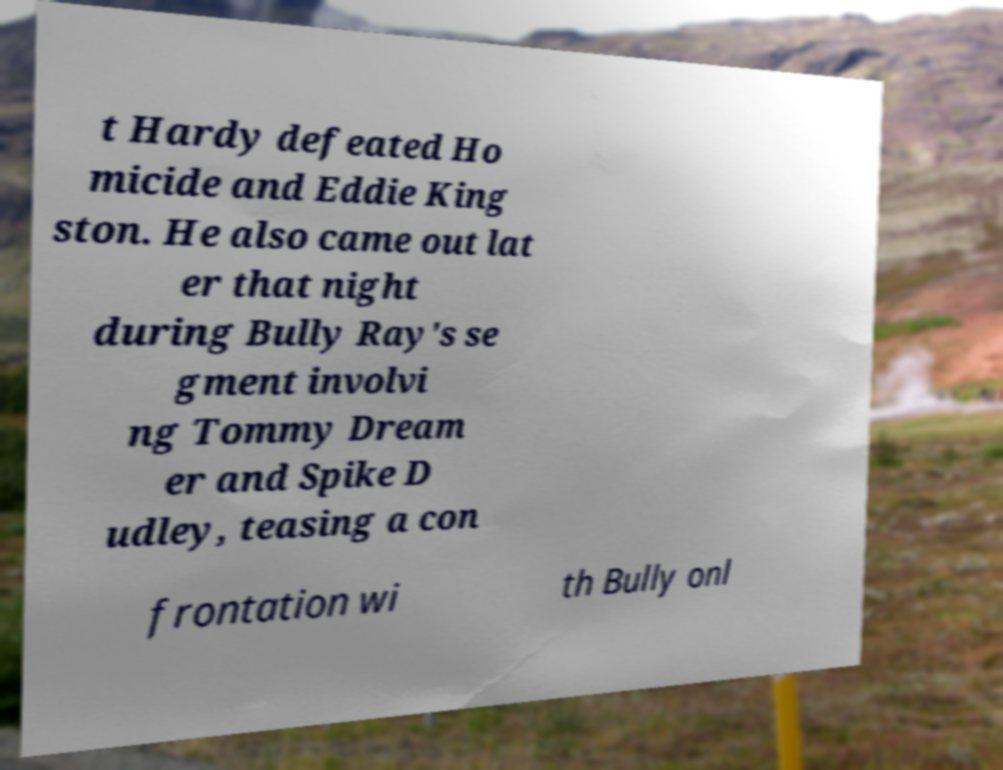What messages or text are displayed in this image? I need them in a readable, typed format. t Hardy defeated Ho micide and Eddie King ston. He also came out lat er that night during Bully Ray's se gment involvi ng Tommy Dream er and Spike D udley, teasing a con frontation wi th Bully onl 